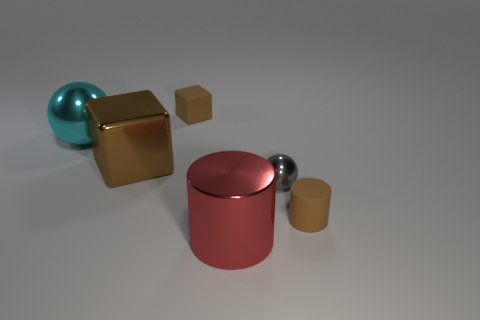What number of objects are either shiny balls right of the large red shiny thing or small objects?
Provide a short and direct response. 3. What shape is the red metal thing that is the same size as the cyan metal sphere?
Provide a succinct answer. Cylinder. There is a sphere that is on the left side of the tiny sphere; is its size the same as the gray object that is to the right of the large brown shiny thing?
Provide a succinct answer. No. What is the color of the object that is the same material as the tiny brown cylinder?
Make the answer very short. Brown. Is the material of the cube behind the large ball the same as the block in front of the matte cube?
Your response must be concise. No. Is there a cyan object of the same size as the brown cylinder?
Keep it short and to the point. No. What size is the thing in front of the brown thing right of the large cylinder?
Ensure brevity in your answer.  Large. What number of tiny cylinders are the same color as the large ball?
Provide a short and direct response. 0. What shape is the brown object behind the large brown metal thing behind the red object?
Make the answer very short. Cube. How many tiny brown blocks have the same material as the big cyan ball?
Provide a short and direct response. 0. 